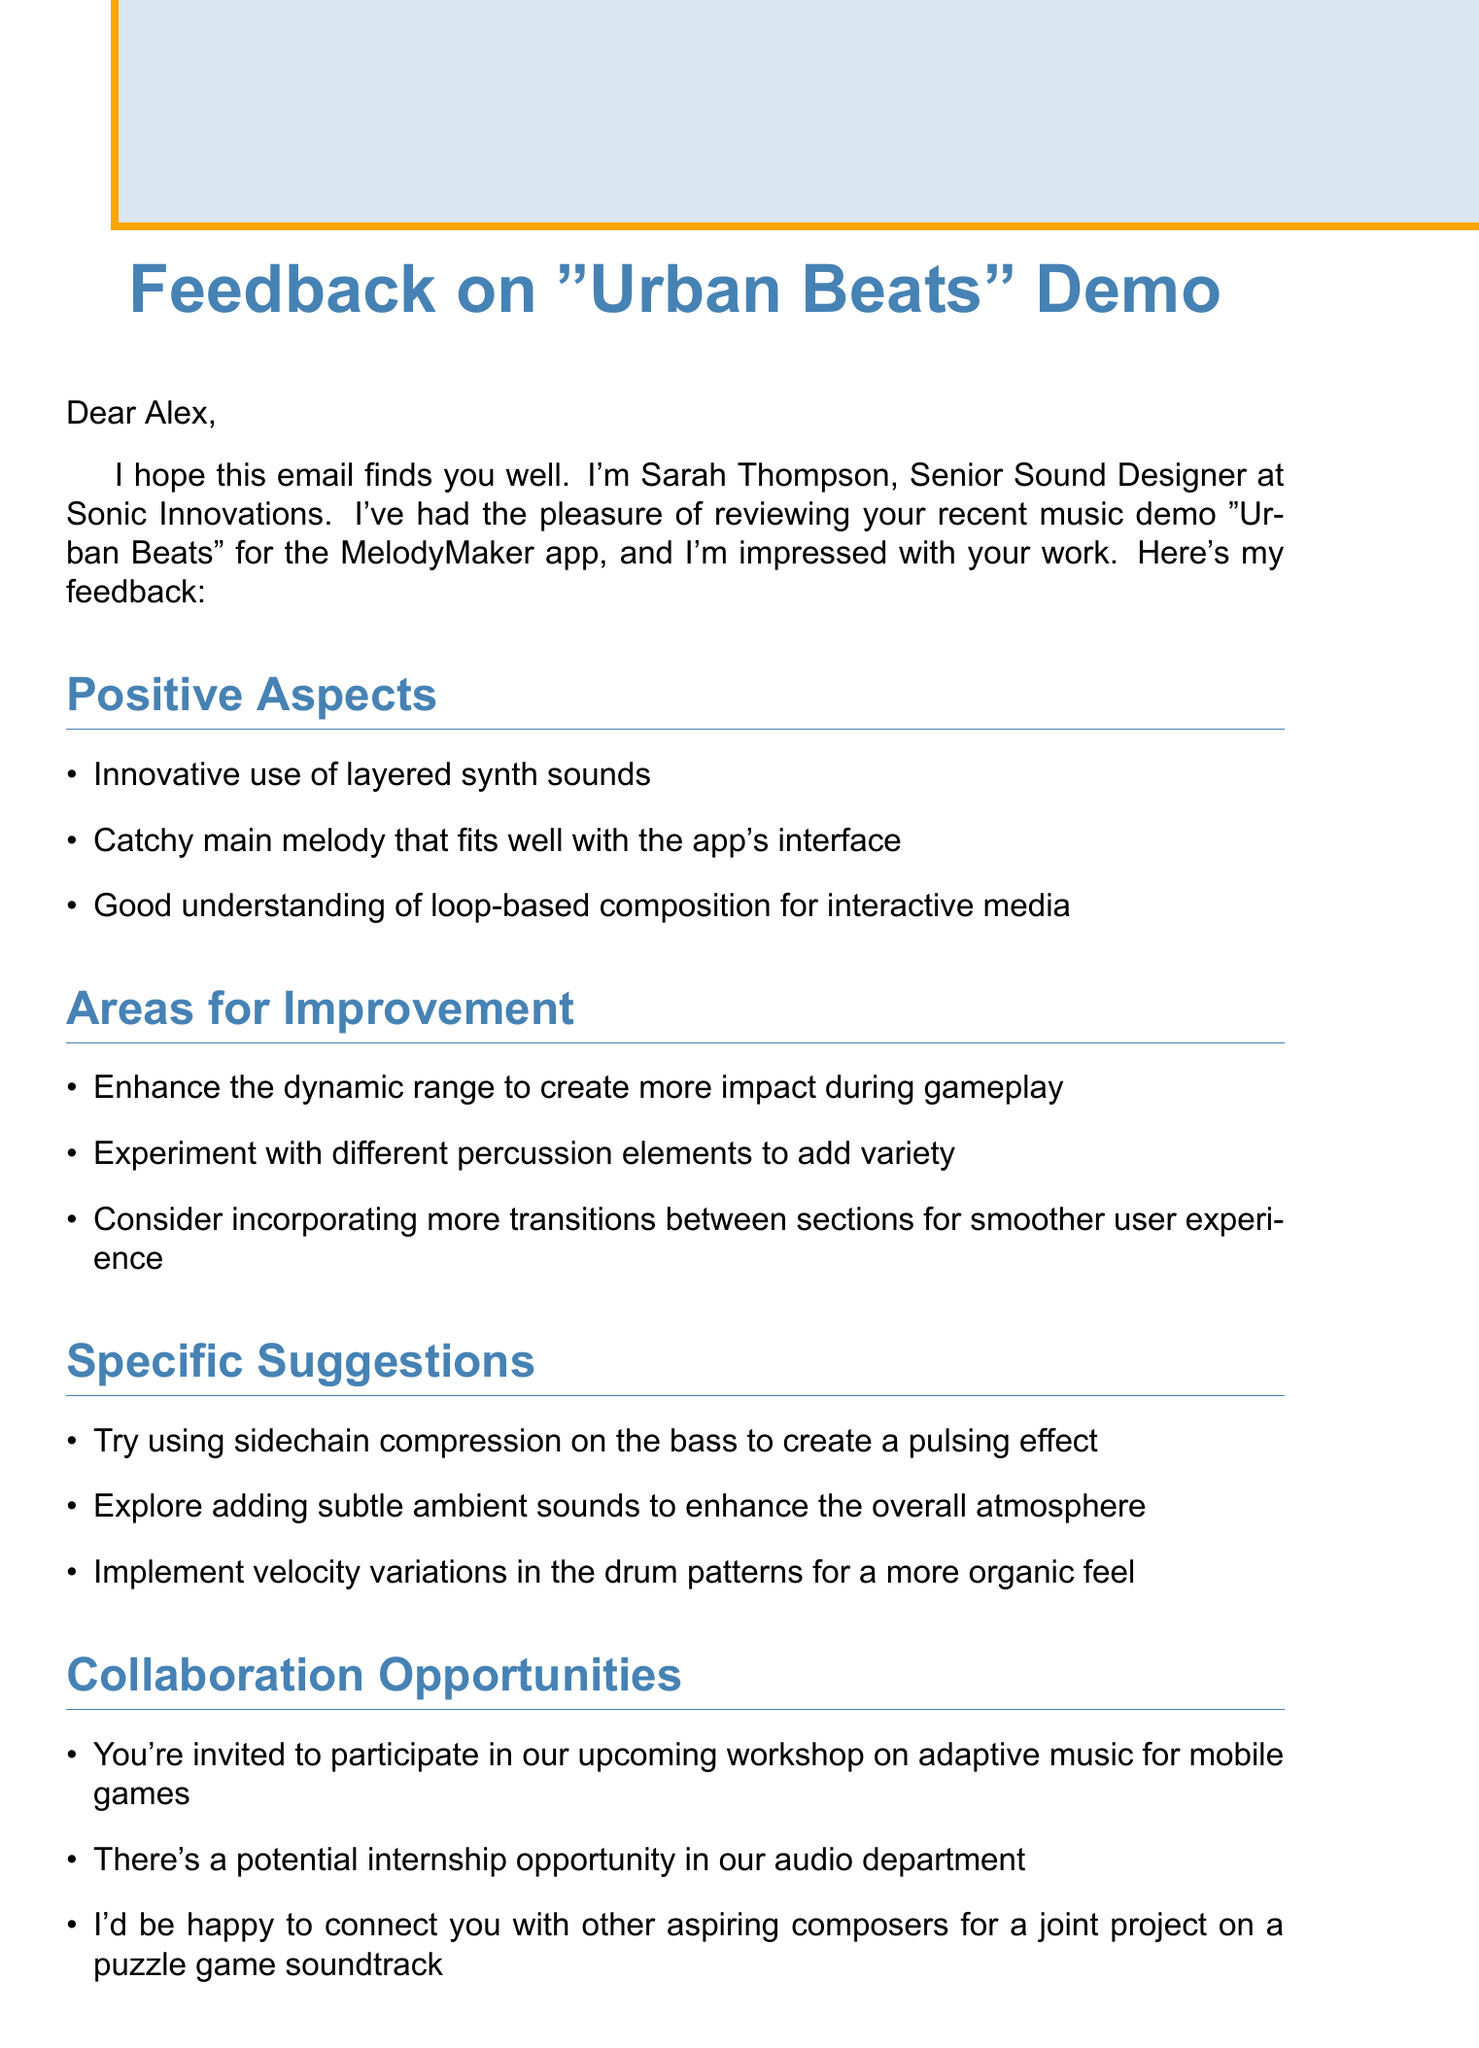What is the mentor's name? The mentor's name is mentioned at the beginning of the document.
Answer: Sarah Thompson What is the title of the demo? The title of the demo is specified in the introduction.
Answer: Urban Beats What are two areas for improvement suggested? Two areas for improvement can be found in the feedback section of the document.
Answer: Enhance the dynamic range, Experiment with different percussion elements What workshop is mentioned in the collaboration opportunities? The document specifies a workshop related to the game's audio in the collaboration section.
Answer: Workshop on adaptive music for mobile games How many specific suggestions were provided? The number of specific suggestions can be counted in the corresponding section of the document.
Answer: Three What audio middleware is recommended to stay updated with? The mentor advises the recipient to learn about a specific audio software in the document.
Answer: FMOD or Wwise What is the mentor's position? The mentor's position is stated in the closing section of the document.
Answer: Senior Sound Designer What is the closing remark about the recipient's talent? The closing remark reflects on the recipient's abilities and future growth potential.
Answer: Your talent and dedication are evident What does the mentor invite the recipient to do? The mentor offers encouragement and openness to future interactions with the recipient.
Answer: Reach out for further guidance 